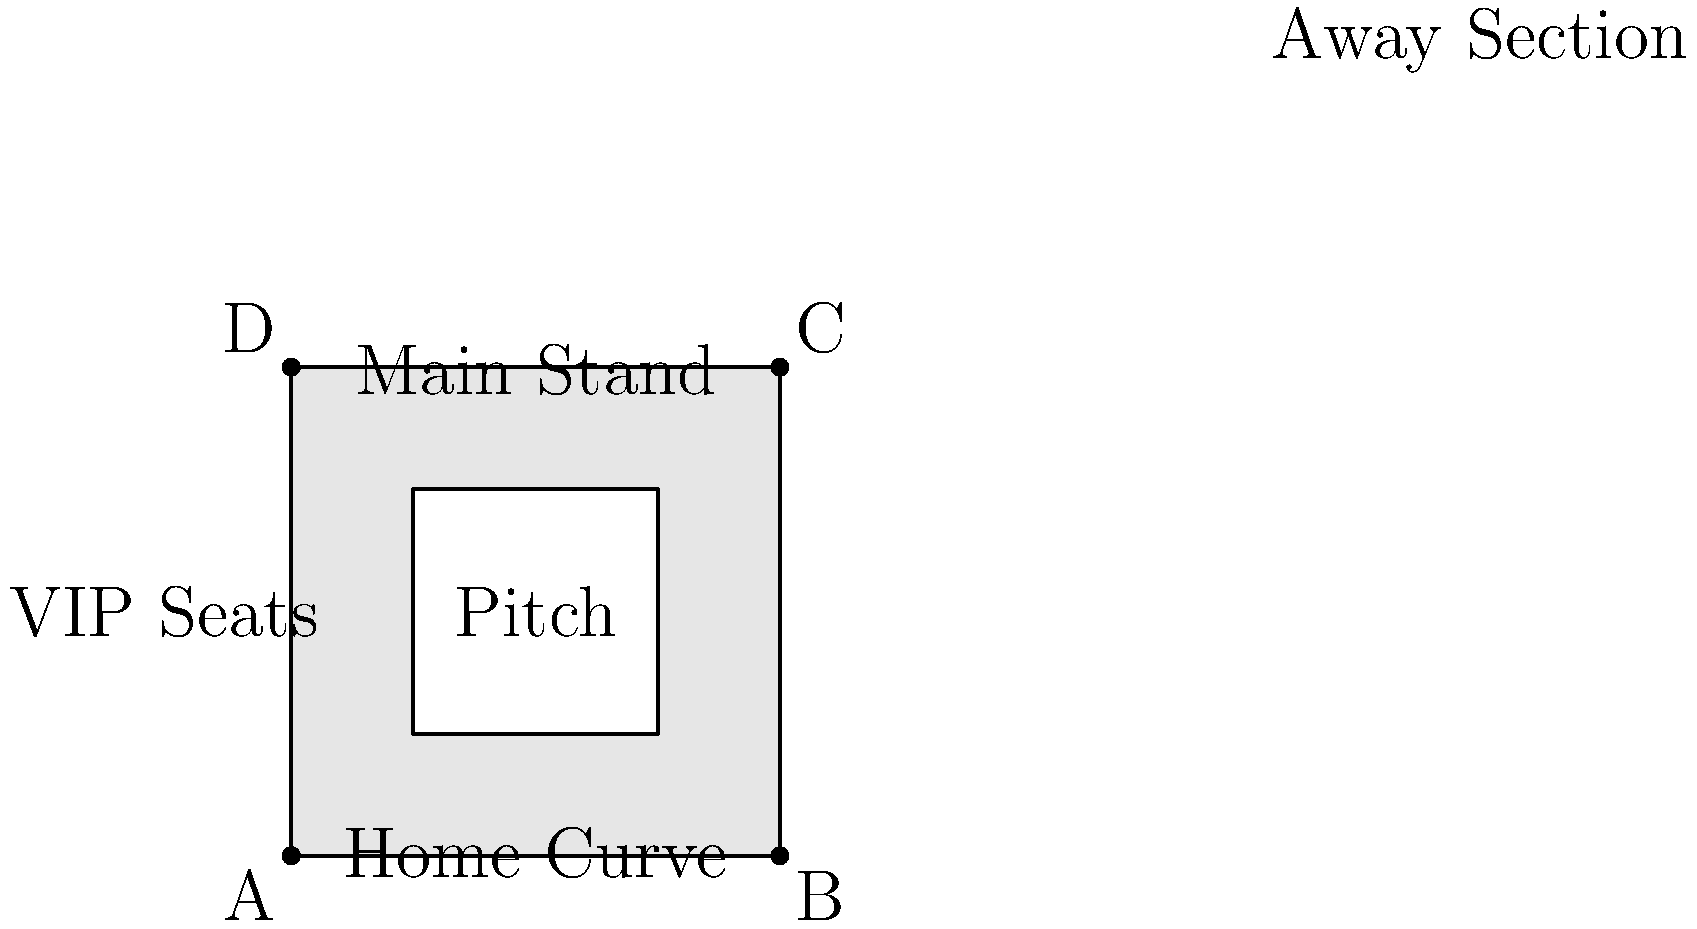In the seating arrangement of Feralpisalò's home stadium, which topological property is exhibited by the relationship between the main seating areas and the pitch? To answer this question, let's analyze the topological properties of the stadium seating arrangement:

1. The stadium has four main seating areas surrounding the pitch: Main Stand, Away Section, Home Curve, and VIP Seats.

2. These seating areas form a closed loop around the central pitch area.

3. In topological terms, this arrangement forms a simple closed curve that encloses the pitch.

4. The pitch can be considered as the interior of this closed curve, while the seating areas form the boundary.

5. This topological relationship is known as the Jordan Curve Theorem, which states that a simple closed curve divides the plane into two regions: an interior and an exterior.

6. In this case, the seating areas (the curve) separate the interior (the pitch) from the exterior (areas outside the stadium).

7. This property is preserved under continuous deformations, making it a topological invariant.

Therefore, the topological property exhibited by the relationship between the main seating areas and the pitch is that of a Jordan curve, where the seating areas form a simple closed curve enclosing the pitch.
Answer: Jordan curve property 